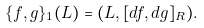Convert formula to latex. <formula><loc_0><loc_0><loc_500><loc_500>\{ f , g \} _ { 1 } ( L ) = ( L , [ d f , d g ] _ { R } ) .</formula> 